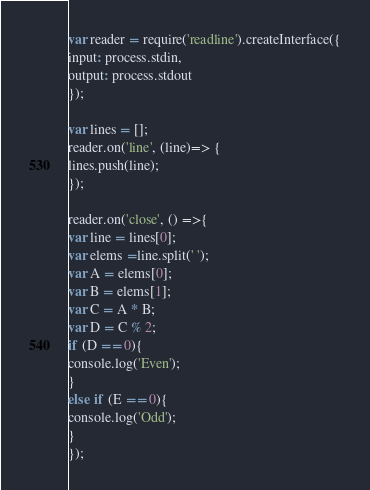<code> <loc_0><loc_0><loc_500><loc_500><_JavaScript_>var reader = require('readline').createInterface({
input: process.stdin,
output: process.stdout
});
 
var lines = [];
reader.on('line', (line)=> {
lines.push(line);
});
 
reader.on('close', () =>{
var line = lines[0];
var elems =line.split(' ');
var A = elems[0];
var B = elems[1];
var C = A * B;
var D = C % 2;
if (D == 0){
console.log('Even');
}
else if (E == 0){
console.log('Odd');
}
});</code> 